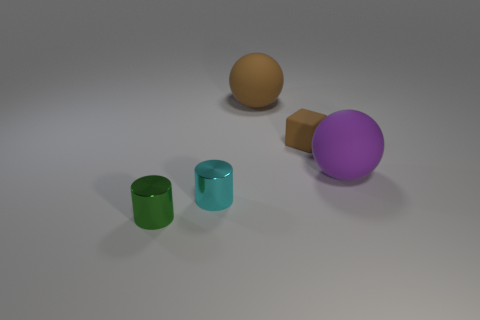Add 3 small green objects. How many objects exist? 8 Subtract all cyan cylinders. How many cylinders are left? 1 Subtract 1 cylinders. How many cylinders are left? 1 Subtract all cylinders. How many objects are left? 3 Subtract all brown cubes. Subtract all small brown rubber objects. How many objects are left? 3 Add 1 green metal cylinders. How many green metal cylinders are left? 2 Add 4 small brown shiny cylinders. How many small brown shiny cylinders exist? 4 Subtract 0 gray spheres. How many objects are left? 5 Subtract all cyan cubes. Subtract all red cylinders. How many cubes are left? 1 